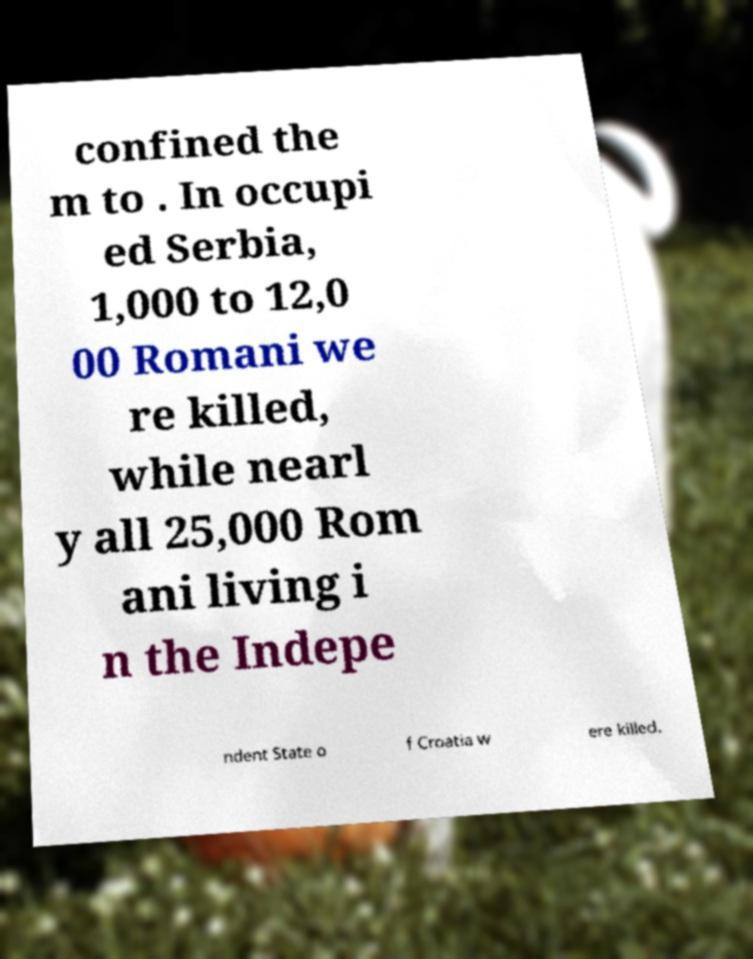For documentation purposes, I need the text within this image transcribed. Could you provide that? confined the m to . In occupi ed Serbia, 1,000 to 12,0 00 Romani we re killed, while nearl y all 25,000 Rom ani living i n the Indepe ndent State o f Croatia w ere killed. 